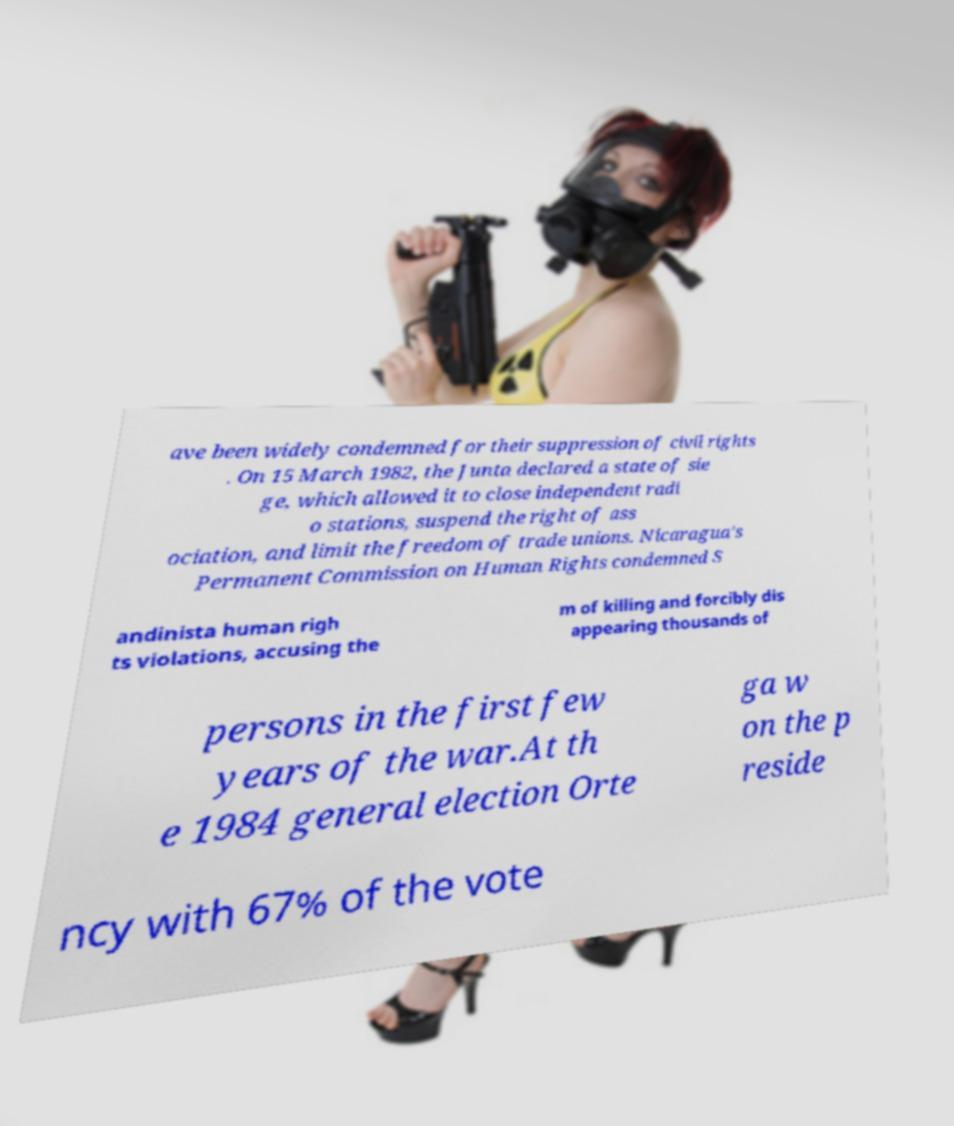Can you read and provide the text displayed in the image?This photo seems to have some interesting text. Can you extract and type it out for me? ave been widely condemned for their suppression of civil rights . On 15 March 1982, the Junta declared a state of sie ge, which allowed it to close independent radi o stations, suspend the right of ass ociation, and limit the freedom of trade unions. Nicaragua's Permanent Commission on Human Rights condemned S andinista human righ ts violations, accusing the m of killing and forcibly dis appearing thousands of persons in the first few years of the war.At th e 1984 general election Orte ga w on the p reside ncy with 67% of the vote 